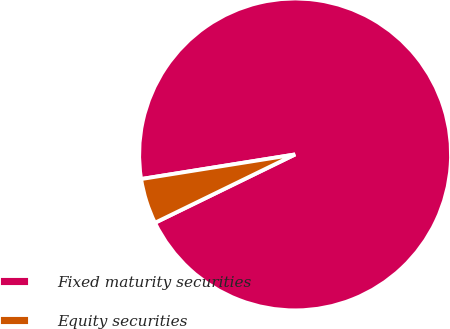Convert chart to OTSL. <chart><loc_0><loc_0><loc_500><loc_500><pie_chart><fcel>Fixed maturity securities<fcel>Equity securities<nl><fcel>95.3%<fcel>4.7%<nl></chart> 